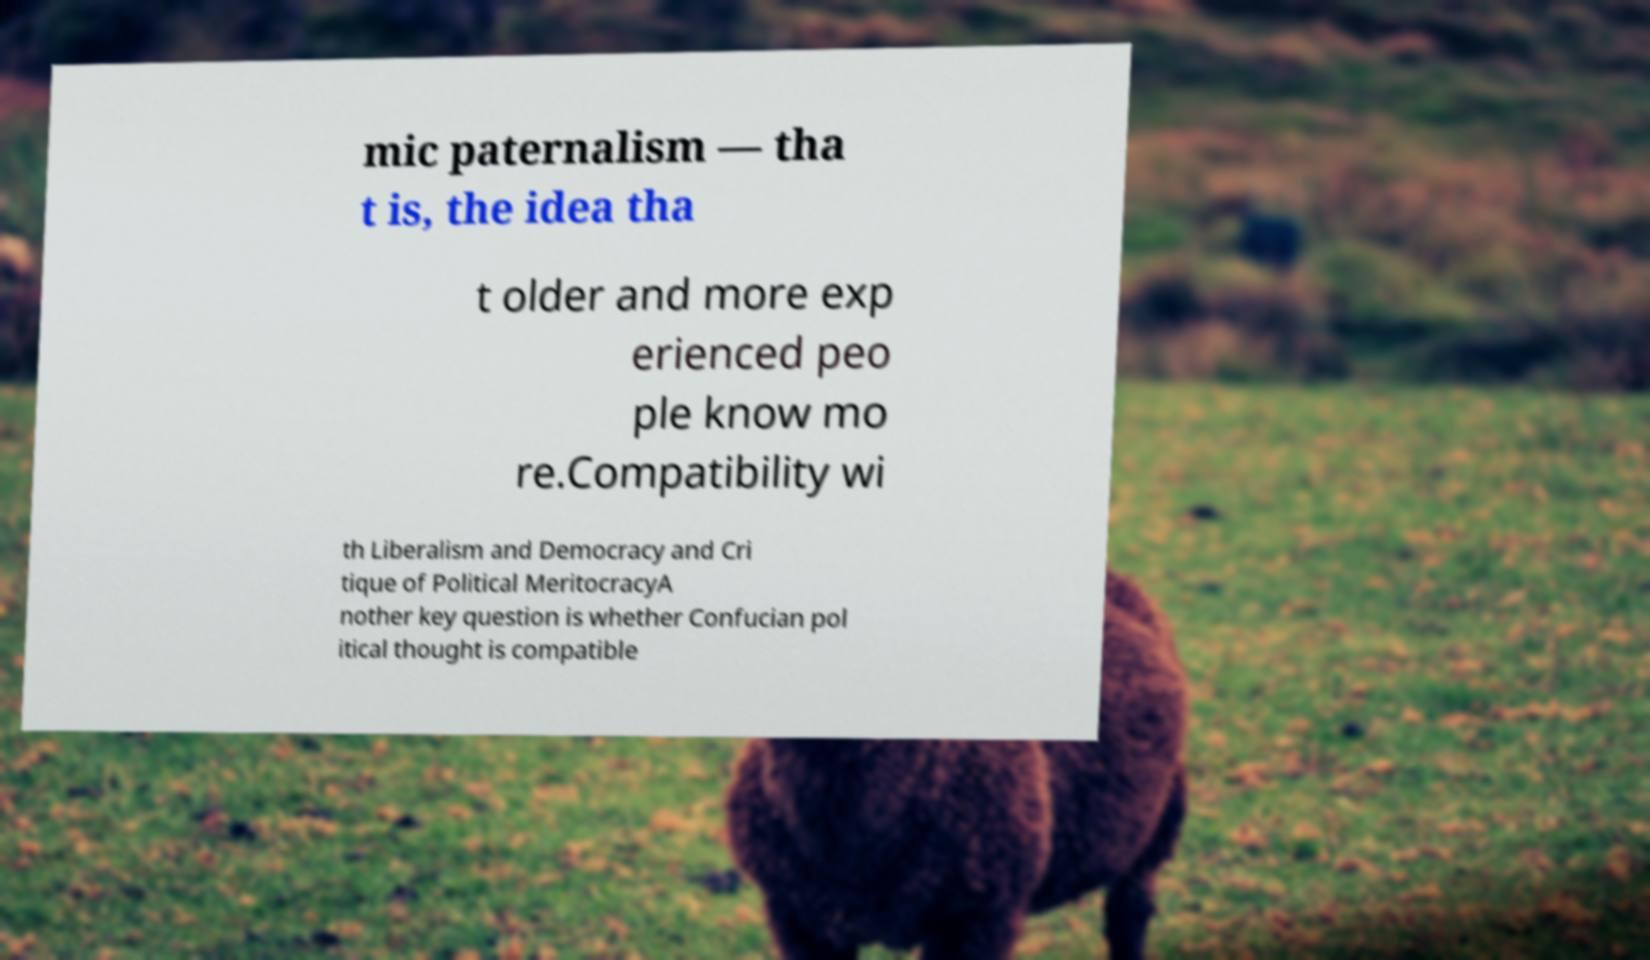There's text embedded in this image that I need extracted. Can you transcribe it verbatim? mic paternalism — tha t is, the idea tha t older and more exp erienced peo ple know mo re.Compatibility wi th Liberalism and Democracy and Cri tique of Political MeritocracyA nother key question is whether Confucian pol itical thought is compatible 